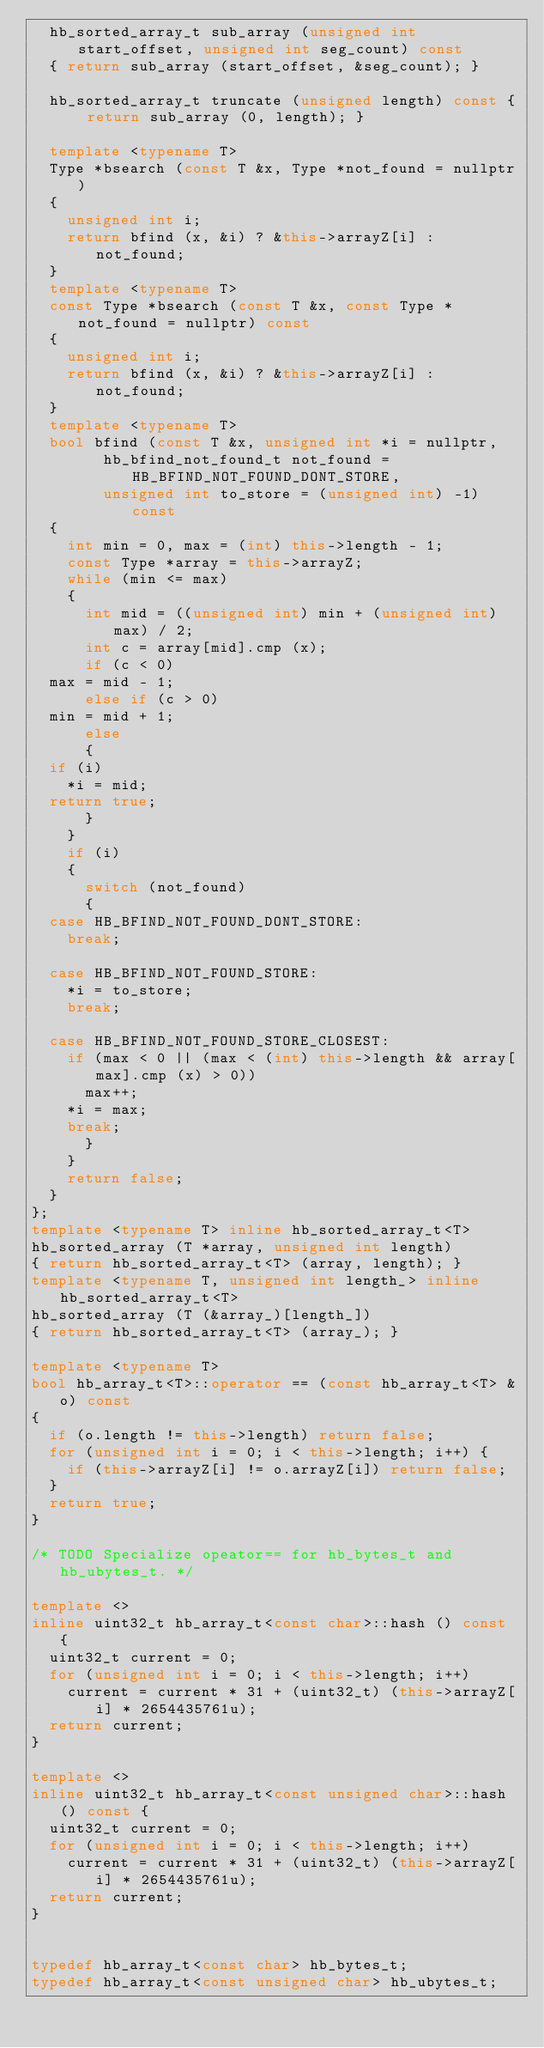Convert code to text. <code><loc_0><loc_0><loc_500><loc_500><_C++_>  hb_sorted_array_t sub_array (unsigned int start_offset, unsigned int seg_count) const
  { return sub_array (start_offset, &seg_count); }

  hb_sorted_array_t truncate (unsigned length) const { return sub_array (0, length); }

  template <typename T>
  Type *bsearch (const T &x, Type *not_found = nullptr)
  {
    unsigned int i;
    return bfind (x, &i) ? &this->arrayZ[i] : not_found;
  }
  template <typename T>
  const Type *bsearch (const T &x, const Type *not_found = nullptr) const
  {
    unsigned int i;
    return bfind (x, &i) ? &this->arrayZ[i] : not_found;
  }
  template <typename T>
  bool bfind (const T &x, unsigned int *i = nullptr,
	      hb_bfind_not_found_t not_found = HB_BFIND_NOT_FOUND_DONT_STORE,
	      unsigned int to_store = (unsigned int) -1) const
  {
    int min = 0, max = (int) this->length - 1;
    const Type *array = this->arrayZ;
    while (min <= max)
    {
      int mid = ((unsigned int) min + (unsigned int) max) / 2;
      int c = array[mid].cmp (x);
      if (c < 0)
	max = mid - 1;
      else if (c > 0)
	min = mid + 1;
      else
      {
	if (i)
	  *i = mid;
	return true;
      }
    }
    if (i)
    {
      switch (not_found)
      {
	case HB_BFIND_NOT_FOUND_DONT_STORE:
	  break;

	case HB_BFIND_NOT_FOUND_STORE:
	  *i = to_store;
	  break;

	case HB_BFIND_NOT_FOUND_STORE_CLOSEST:
	  if (max < 0 || (max < (int) this->length && array[max].cmp (x) > 0))
	    max++;
	  *i = max;
	  break;
      }
    }
    return false;
  }
};
template <typename T> inline hb_sorted_array_t<T>
hb_sorted_array (T *array, unsigned int length)
{ return hb_sorted_array_t<T> (array, length); }
template <typename T, unsigned int length_> inline hb_sorted_array_t<T>
hb_sorted_array (T (&array_)[length_])
{ return hb_sorted_array_t<T> (array_); }

template <typename T>
bool hb_array_t<T>::operator == (const hb_array_t<T> &o) const
{
  if (o.length != this->length) return false;
  for (unsigned int i = 0; i < this->length; i++) {
    if (this->arrayZ[i] != o.arrayZ[i]) return false;
  }
  return true;
}

/* TODO Specialize opeator== for hb_bytes_t and hb_ubytes_t. */

template <>
inline uint32_t hb_array_t<const char>::hash () const {
  uint32_t current = 0;
  for (unsigned int i = 0; i < this->length; i++)
    current = current * 31 + (uint32_t) (this->arrayZ[i] * 2654435761u);
  return current;
}

template <>
inline uint32_t hb_array_t<const unsigned char>::hash () const {
  uint32_t current = 0;
  for (unsigned int i = 0; i < this->length; i++)
    current = current * 31 + (uint32_t) (this->arrayZ[i] * 2654435761u);
  return current;
}


typedef hb_array_t<const char> hb_bytes_t;
typedef hb_array_t<const unsigned char> hb_ubytes_t;
</code> 